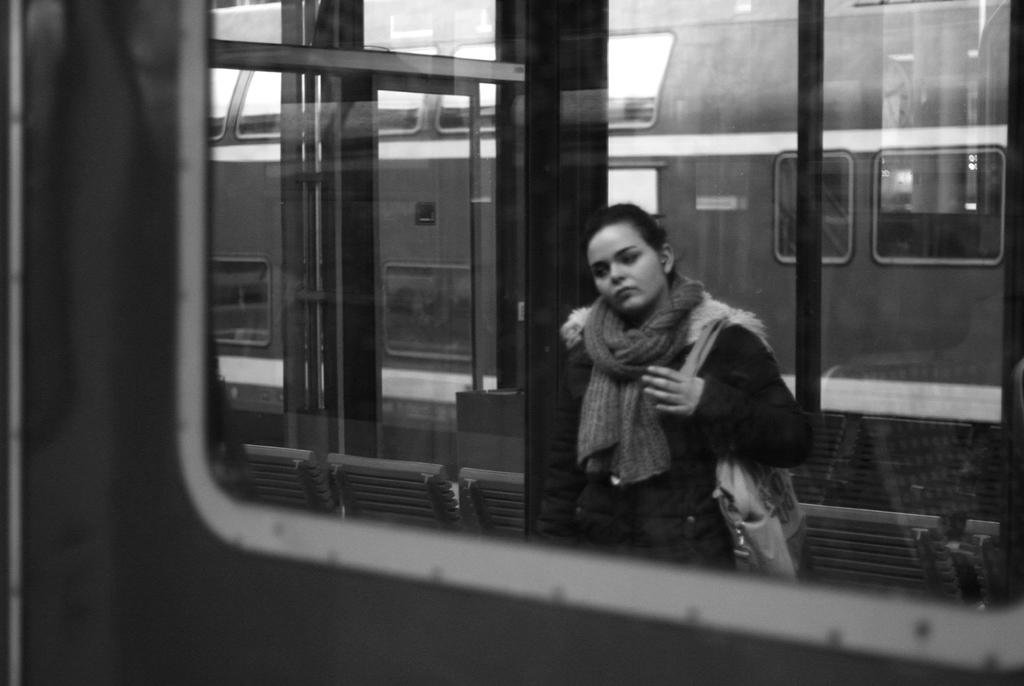What is the main subject of the image? There is a train in the image. What else can be seen in the image besides the train? There are chairs in the image. Can you describe the person in the image? A person is wearing a handbag on her shoulder. What detail can be observed on the glasses in the image? There are reflections on the glasses. What type of cap is the person wearing on the airplane in the image? There is no airplane present in the image, and the person is not wearing a cap. 